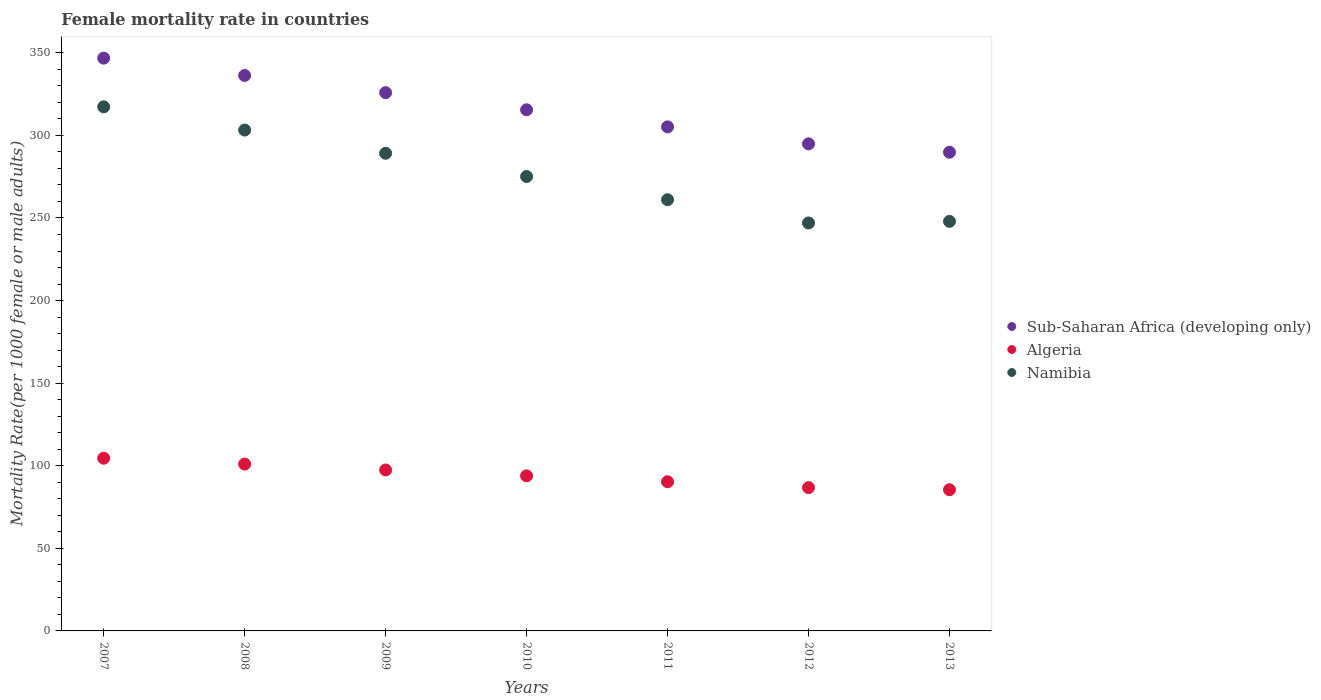What is the female mortality rate in Sub-Saharan Africa (developing only) in 2007?
Provide a short and direct response. 346.77. Across all years, what is the maximum female mortality rate in Sub-Saharan Africa (developing only)?
Your response must be concise. 346.77. Across all years, what is the minimum female mortality rate in Algeria?
Keep it short and to the point. 85.48. In which year was the female mortality rate in Sub-Saharan Africa (developing only) maximum?
Your response must be concise. 2007. In which year was the female mortality rate in Namibia minimum?
Keep it short and to the point. 2012. What is the total female mortality rate in Namibia in the graph?
Offer a terse response. 1940.83. What is the difference between the female mortality rate in Namibia in 2009 and that in 2010?
Offer a terse response. 14.06. What is the difference between the female mortality rate in Sub-Saharan Africa (developing only) in 2011 and the female mortality rate in Namibia in 2010?
Offer a very short reply. 30.05. What is the average female mortality rate in Sub-Saharan Africa (developing only) per year?
Make the answer very short. 316.33. In the year 2013, what is the difference between the female mortality rate in Algeria and female mortality rate in Sub-Saharan Africa (developing only)?
Make the answer very short. -204.33. What is the ratio of the female mortality rate in Namibia in 2010 to that in 2013?
Your response must be concise. 1.11. Is the female mortality rate in Namibia in 2009 less than that in 2011?
Make the answer very short. No. Is the difference between the female mortality rate in Algeria in 2008 and 2009 greater than the difference between the female mortality rate in Sub-Saharan Africa (developing only) in 2008 and 2009?
Provide a short and direct response. No. What is the difference between the highest and the second highest female mortality rate in Namibia?
Make the answer very short. 14.06. What is the difference between the highest and the lowest female mortality rate in Namibia?
Ensure brevity in your answer.  70.31. Is the sum of the female mortality rate in Sub-Saharan Africa (developing only) in 2011 and 2013 greater than the maximum female mortality rate in Namibia across all years?
Your response must be concise. Yes. Is it the case that in every year, the sum of the female mortality rate in Sub-Saharan Africa (developing only) and female mortality rate in Namibia  is greater than the female mortality rate in Algeria?
Ensure brevity in your answer.  Yes. Does the female mortality rate in Namibia monotonically increase over the years?
Your response must be concise. No. Is the female mortality rate in Algeria strictly less than the female mortality rate in Namibia over the years?
Your response must be concise. Yes. How many years are there in the graph?
Your answer should be compact. 7. What is the difference between two consecutive major ticks on the Y-axis?
Give a very brief answer. 50. Are the values on the major ticks of Y-axis written in scientific E-notation?
Give a very brief answer. No. Does the graph contain any zero values?
Give a very brief answer. No. Does the graph contain grids?
Provide a succinct answer. No. Where does the legend appear in the graph?
Your response must be concise. Center right. What is the title of the graph?
Provide a succinct answer. Female mortality rate in countries. Does "El Salvador" appear as one of the legend labels in the graph?
Your answer should be compact. No. What is the label or title of the X-axis?
Offer a very short reply. Years. What is the label or title of the Y-axis?
Provide a succinct answer. Mortality Rate(per 1000 female or male adults). What is the Mortality Rate(per 1000 female or male adults) of Sub-Saharan Africa (developing only) in 2007?
Offer a terse response. 346.77. What is the Mortality Rate(per 1000 female or male adults) in Algeria in 2007?
Make the answer very short. 104.57. What is the Mortality Rate(per 1000 female or male adults) of Namibia in 2007?
Give a very brief answer. 317.3. What is the Mortality Rate(per 1000 female or male adults) in Sub-Saharan Africa (developing only) in 2008?
Offer a terse response. 336.3. What is the Mortality Rate(per 1000 female or male adults) of Algeria in 2008?
Offer a very short reply. 101.01. What is the Mortality Rate(per 1000 female or male adults) of Namibia in 2008?
Your answer should be compact. 303.24. What is the Mortality Rate(per 1000 female or male adults) of Sub-Saharan Africa (developing only) in 2009?
Your answer should be very brief. 325.87. What is the Mortality Rate(per 1000 female or male adults) in Algeria in 2009?
Your answer should be compact. 97.44. What is the Mortality Rate(per 1000 female or male adults) in Namibia in 2009?
Offer a terse response. 289.17. What is the Mortality Rate(per 1000 female or male adults) of Sub-Saharan Africa (developing only) in 2010?
Give a very brief answer. 315.49. What is the Mortality Rate(per 1000 female or male adults) of Algeria in 2010?
Offer a terse response. 93.88. What is the Mortality Rate(per 1000 female or male adults) of Namibia in 2010?
Provide a short and direct response. 275.11. What is the Mortality Rate(per 1000 female or male adults) of Sub-Saharan Africa (developing only) in 2011?
Provide a succinct answer. 305.17. What is the Mortality Rate(per 1000 female or male adults) in Algeria in 2011?
Make the answer very short. 90.32. What is the Mortality Rate(per 1000 female or male adults) in Namibia in 2011?
Offer a terse response. 261.05. What is the Mortality Rate(per 1000 female or male adults) of Sub-Saharan Africa (developing only) in 2012?
Make the answer very short. 294.88. What is the Mortality Rate(per 1000 female or male adults) of Algeria in 2012?
Ensure brevity in your answer.  86.75. What is the Mortality Rate(per 1000 female or male adults) in Namibia in 2012?
Make the answer very short. 246.99. What is the Mortality Rate(per 1000 female or male adults) in Sub-Saharan Africa (developing only) in 2013?
Offer a very short reply. 289.81. What is the Mortality Rate(per 1000 female or male adults) in Algeria in 2013?
Keep it short and to the point. 85.48. What is the Mortality Rate(per 1000 female or male adults) of Namibia in 2013?
Your response must be concise. 247.97. Across all years, what is the maximum Mortality Rate(per 1000 female or male adults) in Sub-Saharan Africa (developing only)?
Ensure brevity in your answer.  346.77. Across all years, what is the maximum Mortality Rate(per 1000 female or male adults) of Algeria?
Keep it short and to the point. 104.57. Across all years, what is the maximum Mortality Rate(per 1000 female or male adults) of Namibia?
Your answer should be compact. 317.3. Across all years, what is the minimum Mortality Rate(per 1000 female or male adults) of Sub-Saharan Africa (developing only)?
Make the answer very short. 289.81. Across all years, what is the minimum Mortality Rate(per 1000 female or male adults) in Algeria?
Provide a short and direct response. 85.48. Across all years, what is the minimum Mortality Rate(per 1000 female or male adults) of Namibia?
Give a very brief answer. 246.99. What is the total Mortality Rate(per 1000 female or male adults) of Sub-Saharan Africa (developing only) in the graph?
Offer a terse response. 2214.28. What is the total Mortality Rate(per 1000 female or male adults) in Algeria in the graph?
Keep it short and to the point. 659.45. What is the total Mortality Rate(per 1000 female or male adults) in Namibia in the graph?
Give a very brief answer. 1940.83. What is the difference between the Mortality Rate(per 1000 female or male adults) in Sub-Saharan Africa (developing only) in 2007 and that in 2008?
Make the answer very short. 10.47. What is the difference between the Mortality Rate(per 1000 female or male adults) in Algeria in 2007 and that in 2008?
Give a very brief answer. 3.56. What is the difference between the Mortality Rate(per 1000 female or male adults) of Namibia in 2007 and that in 2008?
Your answer should be very brief. 14.06. What is the difference between the Mortality Rate(per 1000 female or male adults) in Sub-Saharan Africa (developing only) in 2007 and that in 2009?
Keep it short and to the point. 20.9. What is the difference between the Mortality Rate(per 1000 female or male adults) in Algeria in 2007 and that in 2009?
Provide a short and direct response. 7.13. What is the difference between the Mortality Rate(per 1000 female or male adults) in Namibia in 2007 and that in 2009?
Keep it short and to the point. 28.12. What is the difference between the Mortality Rate(per 1000 female or male adults) of Sub-Saharan Africa (developing only) in 2007 and that in 2010?
Offer a terse response. 31.27. What is the difference between the Mortality Rate(per 1000 female or male adults) of Algeria in 2007 and that in 2010?
Offer a terse response. 10.69. What is the difference between the Mortality Rate(per 1000 female or male adults) of Namibia in 2007 and that in 2010?
Keep it short and to the point. 42.19. What is the difference between the Mortality Rate(per 1000 female or male adults) of Sub-Saharan Africa (developing only) in 2007 and that in 2011?
Provide a short and direct response. 41.6. What is the difference between the Mortality Rate(per 1000 female or male adults) of Algeria in 2007 and that in 2011?
Give a very brief answer. 14.25. What is the difference between the Mortality Rate(per 1000 female or male adults) of Namibia in 2007 and that in 2011?
Offer a very short reply. 56.25. What is the difference between the Mortality Rate(per 1000 female or male adults) of Sub-Saharan Africa (developing only) in 2007 and that in 2012?
Provide a short and direct response. 51.89. What is the difference between the Mortality Rate(per 1000 female or male adults) in Algeria in 2007 and that in 2012?
Provide a succinct answer. 17.82. What is the difference between the Mortality Rate(per 1000 female or male adults) in Namibia in 2007 and that in 2012?
Provide a succinct answer. 70.31. What is the difference between the Mortality Rate(per 1000 female or male adults) in Sub-Saharan Africa (developing only) in 2007 and that in 2013?
Provide a short and direct response. 56.95. What is the difference between the Mortality Rate(per 1000 female or male adults) of Algeria in 2007 and that in 2013?
Keep it short and to the point. 19.09. What is the difference between the Mortality Rate(per 1000 female or male adults) of Namibia in 2007 and that in 2013?
Ensure brevity in your answer.  69.33. What is the difference between the Mortality Rate(per 1000 female or male adults) in Sub-Saharan Africa (developing only) in 2008 and that in 2009?
Offer a very short reply. 10.43. What is the difference between the Mortality Rate(per 1000 female or male adults) in Algeria in 2008 and that in 2009?
Keep it short and to the point. 3.56. What is the difference between the Mortality Rate(per 1000 female or male adults) in Namibia in 2008 and that in 2009?
Your response must be concise. 14.06. What is the difference between the Mortality Rate(per 1000 female or male adults) in Sub-Saharan Africa (developing only) in 2008 and that in 2010?
Offer a very short reply. 20.81. What is the difference between the Mortality Rate(per 1000 female or male adults) in Algeria in 2008 and that in 2010?
Provide a short and direct response. 7.13. What is the difference between the Mortality Rate(per 1000 female or male adults) in Namibia in 2008 and that in 2010?
Your response must be concise. 28.12. What is the difference between the Mortality Rate(per 1000 female or male adults) of Sub-Saharan Africa (developing only) in 2008 and that in 2011?
Your answer should be compact. 31.13. What is the difference between the Mortality Rate(per 1000 female or male adults) of Algeria in 2008 and that in 2011?
Provide a short and direct response. 10.69. What is the difference between the Mortality Rate(per 1000 female or male adults) of Namibia in 2008 and that in 2011?
Ensure brevity in your answer.  42.19. What is the difference between the Mortality Rate(per 1000 female or male adults) in Sub-Saharan Africa (developing only) in 2008 and that in 2012?
Your response must be concise. 41.42. What is the difference between the Mortality Rate(per 1000 female or male adults) of Algeria in 2008 and that in 2012?
Make the answer very short. 14.25. What is the difference between the Mortality Rate(per 1000 female or male adults) of Namibia in 2008 and that in 2012?
Your answer should be compact. 56.25. What is the difference between the Mortality Rate(per 1000 female or male adults) of Sub-Saharan Africa (developing only) in 2008 and that in 2013?
Offer a very short reply. 46.49. What is the difference between the Mortality Rate(per 1000 female or male adults) in Algeria in 2008 and that in 2013?
Provide a succinct answer. 15.52. What is the difference between the Mortality Rate(per 1000 female or male adults) in Namibia in 2008 and that in 2013?
Keep it short and to the point. 55.27. What is the difference between the Mortality Rate(per 1000 female or male adults) in Sub-Saharan Africa (developing only) in 2009 and that in 2010?
Offer a terse response. 10.38. What is the difference between the Mortality Rate(per 1000 female or male adults) in Algeria in 2009 and that in 2010?
Your answer should be very brief. 3.56. What is the difference between the Mortality Rate(per 1000 female or male adults) in Namibia in 2009 and that in 2010?
Your answer should be very brief. 14.06. What is the difference between the Mortality Rate(per 1000 female or male adults) in Sub-Saharan Africa (developing only) in 2009 and that in 2011?
Give a very brief answer. 20.71. What is the difference between the Mortality Rate(per 1000 female or male adults) in Algeria in 2009 and that in 2011?
Make the answer very short. 7.13. What is the difference between the Mortality Rate(per 1000 female or male adults) of Namibia in 2009 and that in 2011?
Give a very brief answer. 28.12. What is the difference between the Mortality Rate(per 1000 female or male adults) in Sub-Saharan Africa (developing only) in 2009 and that in 2012?
Provide a succinct answer. 30.99. What is the difference between the Mortality Rate(per 1000 female or male adults) of Algeria in 2009 and that in 2012?
Give a very brief answer. 10.69. What is the difference between the Mortality Rate(per 1000 female or male adults) in Namibia in 2009 and that in 2012?
Your answer should be very brief. 42.19. What is the difference between the Mortality Rate(per 1000 female or male adults) of Sub-Saharan Africa (developing only) in 2009 and that in 2013?
Give a very brief answer. 36.06. What is the difference between the Mortality Rate(per 1000 female or male adults) of Algeria in 2009 and that in 2013?
Give a very brief answer. 11.96. What is the difference between the Mortality Rate(per 1000 female or male adults) in Namibia in 2009 and that in 2013?
Provide a succinct answer. 41.21. What is the difference between the Mortality Rate(per 1000 female or male adults) of Sub-Saharan Africa (developing only) in 2010 and that in 2011?
Provide a succinct answer. 10.33. What is the difference between the Mortality Rate(per 1000 female or male adults) of Algeria in 2010 and that in 2011?
Your response must be concise. 3.56. What is the difference between the Mortality Rate(per 1000 female or male adults) of Namibia in 2010 and that in 2011?
Offer a very short reply. 14.06. What is the difference between the Mortality Rate(per 1000 female or male adults) of Sub-Saharan Africa (developing only) in 2010 and that in 2012?
Your response must be concise. 20.61. What is the difference between the Mortality Rate(per 1000 female or male adults) in Algeria in 2010 and that in 2012?
Your answer should be very brief. 7.13. What is the difference between the Mortality Rate(per 1000 female or male adults) of Namibia in 2010 and that in 2012?
Make the answer very short. 28.12. What is the difference between the Mortality Rate(per 1000 female or male adults) in Sub-Saharan Africa (developing only) in 2010 and that in 2013?
Ensure brevity in your answer.  25.68. What is the difference between the Mortality Rate(per 1000 female or male adults) of Algeria in 2010 and that in 2013?
Offer a very short reply. 8.4. What is the difference between the Mortality Rate(per 1000 female or male adults) in Namibia in 2010 and that in 2013?
Keep it short and to the point. 27.14. What is the difference between the Mortality Rate(per 1000 female or male adults) in Sub-Saharan Africa (developing only) in 2011 and that in 2012?
Make the answer very short. 10.29. What is the difference between the Mortality Rate(per 1000 female or male adults) in Algeria in 2011 and that in 2012?
Your answer should be very brief. 3.56. What is the difference between the Mortality Rate(per 1000 female or male adults) of Namibia in 2011 and that in 2012?
Your response must be concise. 14.06. What is the difference between the Mortality Rate(per 1000 female or male adults) of Sub-Saharan Africa (developing only) in 2011 and that in 2013?
Give a very brief answer. 15.35. What is the difference between the Mortality Rate(per 1000 female or male adults) of Algeria in 2011 and that in 2013?
Provide a succinct answer. 4.83. What is the difference between the Mortality Rate(per 1000 female or male adults) in Namibia in 2011 and that in 2013?
Offer a very short reply. 13.08. What is the difference between the Mortality Rate(per 1000 female or male adults) of Sub-Saharan Africa (developing only) in 2012 and that in 2013?
Keep it short and to the point. 5.07. What is the difference between the Mortality Rate(per 1000 female or male adults) of Algeria in 2012 and that in 2013?
Make the answer very short. 1.27. What is the difference between the Mortality Rate(per 1000 female or male adults) in Namibia in 2012 and that in 2013?
Offer a very short reply. -0.98. What is the difference between the Mortality Rate(per 1000 female or male adults) in Sub-Saharan Africa (developing only) in 2007 and the Mortality Rate(per 1000 female or male adults) in Algeria in 2008?
Your response must be concise. 245.76. What is the difference between the Mortality Rate(per 1000 female or male adults) in Sub-Saharan Africa (developing only) in 2007 and the Mortality Rate(per 1000 female or male adults) in Namibia in 2008?
Give a very brief answer. 43.53. What is the difference between the Mortality Rate(per 1000 female or male adults) of Algeria in 2007 and the Mortality Rate(per 1000 female or male adults) of Namibia in 2008?
Your response must be concise. -198.67. What is the difference between the Mortality Rate(per 1000 female or male adults) of Sub-Saharan Africa (developing only) in 2007 and the Mortality Rate(per 1000 female or male adults) of Algeria in 2009?
Offer a terse response. 249.32. What is the difference between the Mortality Rate(per 1000 female or male adults) of Sub-Saharan Africa (developing only) in 2007 and the Mortality Rate(per 1000 female or male adults) of Namibia in 2009?
Make the answer very short. 57.59. What is the difference between the Mortality Rate(per 1000 female or male adults) of Algeria in 2007 and the Mortality Rate(per 1000 female or male adults) of Namibia in 2009?
Offer a very short reply. -184.6. What is the difference between the Mortality Rate(per 1000 female or male adults) of Sub-Saharan Africa (developing only) in 2007 and the Mortality Rate(per 1000 female or male adults) of Algeria in 2010?
Keep it short and to the point. 252.89. What is the difference between the Mortality Rate(per 1000 female or male adults) of Sub-Saharan Africa (developing only) in 2007 and the Mortality Rate(per 1000 female or male adults) of Namibia in 2010?
Offer a very short reply. 71.65. What is the difference between the Mortality Rate(per 1000 female or male adults) of Algeria in 2007 and the Mortality Rate(per 1000 female or male adults) of Namibia in 2010?
Ensure brevity in your answer.  -170.54. What is the difference between the Mortality Rate(per 1000 female or male adults) of Sub-Saharan Africa (developing only) in 2007 and the Mortality Rate(per 1000 female or male adults) of Algeria in 2011?
Provide a short and direct response. 256.45. What is the difference between the Mortality Rate(per 1000 female or male adults) of Sub-Saharan Africa (developing only) in 2007 and the Mortality Rate(per 1000 female or male adults) of Namibia in 2011?
Make the answer very short. 85.72. What is the difference between the Mortality Rate(per 1000 female or male adults) of Algeria in 2007 and the Mortality Rate(per 1000 female or male adults) of Namibia in 2011?
Offer a very short reply. -156.48. What is the difference between the Mortality Rate(per 1000 female or male adults) in Sub-Saharan Africa (developing only) in 2007 and the Mortality Rate(per 1000 female or male adults) in Algeria in 2012?
Offer a terse response. 260.01. What is the difference between the Mortality Rate(per 1000 female or male adults) of Sub-Saharan Africa (developing only) in 2007 and the Mortality Rate(per 1000 female or male adults) of Namibia in 2012?
Your answer should be very brief. 99.78. What is the difference between the Mortality Rate(per 1000 female or male adults) in Algeria in 2007 and the Mortality Rate(per 1000 female or male adults) in Namibia in 2012?
Your response must be concise. -142.42. What is the difference between the Mortality Rate(per 1000 female or male adults) in Sub-Saharan Africa (developing only) in 2007 and the Mortality Rate(per 1000 female or male adults) in Algeria in 2013?
Your response must be concise. 261.28. What is the difference between the Mortality Rate(per 1000 female or male adults) in Sub-Saharan Africa (developing only) in 2007 and the Mortality Rate(per 1000 female or male adults) in Namibia in 2013?
Your answer should be very brief. 98.8. What is the difference between the Mortality Rate(per 1000 female or male adults) of Algeria in 2007 and the Mortality Rate(per 1000 female or male adults) of Namibia in 2013?
Your response must be concise. -143.4. What is the difference between the Mortality Rate(per 1000 female or male adults) of Sub-Saharan Africa (developing only) in 2008 and the Mortality Rate(per 1000 female or male adults) of Algeria in 2009?
Offer a terse response. 238.85. What is the difference between the Mortality Rate(per 1000 female or male adults) of Sub-Saharan Africa (developing only) in 2008 and the Mortality Rate(per 1000 female or male adults) of Namibia in 2009?
Offer a terse response. 47.12. What is the difference between the Mortality Rate(per 1000 female or male adults) in Algeria in 2008 and the Mortality Rate(per 1000 female or male adults) in Namibia in 2009?
Ensure brevity in your answer.  -188.17. What is the difference between the Mortality Rate(per 1000 female or male adults) in Sub-Saharan Africa (developing only) in 2008 and the Mortality Rate(per 1000 female or male adults) in Algeria in 2010?
Your answer should be very brief. 242.42. What is the difference between the Mortality Rate(per 1000 female or male adults) of Sub-Saharan Africa (developing only) in 2008 and the Mortality Rate(per 1000 female or male adults) of Namibia in 2010?
Your response must be concise. 61.19. What is the difference between the Mortality Rate(per 1000 female or male adults) in Algeria in 2008 and the Mortality Rate(per 1000 female or male adults) in Namibia in 2010?
Your answer should be compact. -174.11. What is the difference between the Mortality Rate(per 1000 female or male adults) of Sub-Saharan Africa (developing only) in 2008 and the Mortality Rate(per 1000 female or male adults) of Algeria in 2011?
Make the answer very short. 245.98. What is the difference between the Mortality Rate(per 1000 female or male adults) in Sub-Saharan Africa (developing only) in 2008 and the Mortality Rate(per 1000 female or male adults) in Namibia in 2011?
Give a very brief answer. 75.25. What is the difference between the Mortality Rate(per 1000 female or male adults) of Algeria in 2008 and the Mortality Rate(per 1000 female or male adults) of Namibia in 2011?
Your answer should be compact. -160.04. What is the difference between the Mortality Rate(per 1000 female or male adults) of Sub-Saharan Africa (developing only) in 2008 and the Mortality Rate(per 1000 female or male adults) of Algeria in 2012?
Keep it short and to the point. 249.54. What is the difference between the Mortality Rate(per 1000 female or male adults) in Sub-Saharan Africa (developing only) in 2008 and the Mortality Rate(per 1000 female or male adults) in Namibia in 2012?
Your response must be concise. 89.31. What is the difference between the Mortality Rate(per 1000 female or male adults) in Algeria in 2008 and the Mortality Rate(per 1000 female or male adults) in Namibia in 2012?
Make the answer very short. -145.98. What is the difference between the Mortality Rate(per 1000 female or male adults) in Sub-Saharan Africa (developing only) in 2008 and the Mortality Rate(per 1000 female or male adults) in Algeria in 2013?
Your answer should be compact. 250.82. What is the difference between the Mortality Rate(per 1000 female or male adults) in Sub-Saharan Africa (developing only) in 2008 and the Mortality Rate(per 1000 female or male adults) in Namibia in 2013?
Your response must be concise. 88.33. What is the difference between the Mortality Rate(per 1000 female or male adults) in Algeria in 2008 and the Mortality Rate(per 1000 female or male adults) in Namibia in 2013?
Make the answer very short. -146.96. What is the difference between the Mortality Rate(per 1000 female or male adults) of Sub-Saharan Africa (developing only) in 2009 and the Mortality Rate(per 1000 female or male adults) of Algeria in 2010?
Ensure brevity in your answer.  231.99. What is the difference between the Mortality Rate(per 1000 female or male adults) in Sub-Saharan Africa (developing only) in 2009 and the Mortality Rate(per 1000 female or male adults) in Namibia in 2010?
Ensure brevity in your answer.  50.76. What is the difference between the Mortality Rate(per 1000 female or male adults) in Algeria in 2009 and the Mortality Rate(per 1000 female or male adults) in Namibia in 2010?
Give a very brief answer. -177.67. What is the difference between the Mortality Rate(per 1000 female or male adults) in Sub-Saharan Africa (developing only) in 2009 and the Mortality Rate(per 1000 female or male adults) in Algeria in 2011?
Provide a short and direct response. 235.55. What is the difference between the Mortality Rate(per 1000 female or male adults) of Sub-Saharan Africa (developing only) in 2009 and the Mortality Rate(per 1000 female or male adults) of Namibia in 2011?
Make the answer very short. 64.82. What is the difference between the Mortality Rate(per 1000 female or male adults) in Algeria in 2009 and the Mortality Rate(per 1000 female or male adults) in Namibia in 2011?
Provide a short and direct response. -163.61. What is the difference between the Mortality Rate(per 1000 female or male adults) in Sub-Saharan Africa (developing only) in 2009 and the Mortality Rate(per 1000 female or male adults) in Algeria in 2012?
Offer a very short reply. 239.12. What is the difference between the Mortality Rate(per 1000 female or male adults) in Sub-Saharan Africa (developing only) in 2009 and the Mortality Rate(per 1000 female or male adults) in Namibia in 2012?
Your answer should be very brief. 78.88. What is the difference between the Mortality Rate(per 1000 female or male adults) in Algeria in 2009 and the Mortality Rate(per 1000 female or male adults) in Namibia in 2012?
Offer a terse response. -149.54. What is the difference between the Mortality Rate(per 1000 female or male adults) in Sub-Saharan Africa (developing only) in 2009 and the Mortality Rate(per 1000 female or male adults) in Algeria in 2013?
Provide a succinct answer. 240.39. What is the difference between the Mortality Rate(per 1000 female or male adults) in Sub-Saharan Africa (developing only) in 2009 and the Mortality Rate(per 1000 female or male adults) in Namibia in 2013?
Offer a very short reply. 77.9. What is the difference between the Mortality Rate(per 1000 female or male adults) in Algeria in 2009 and the Mortality Rate(per 1000 female or male adults) in Namibia in 2013?
Make the answer very short. -150.53. What is the difference between the Mortality Rate(per 1000 female or male adults) of Sub-Saharan Africa (developing only) in 2010 and the Mortality Rate(per 1000 female or male adults) of Algeria in 2011?
Ensure brevity in your answer.  225.18. What is the difference between the Mortality Rate(per 1000 female or male adults) in Sub-Saharan Africa (developing only) in 2010 and the Mortality Rate(per 1000 female or male adults) in Namibia in 2011?
Give a very brief answer. 54.44. What is the difference between the Mortality Rate(per 1000 female or male adults) of Algeria in 2010 and the Mortality Rate(per 1000 female or male adults) of Namibia in 2011?
Your response must be concise. -167.17. What is the difference between the Mortality Rate(per 1000 female or male adults) of Sub-Saharan Africa (developing only) in 2010 and the Mortality Rate(per 1000 female or male adults) of Algeria in 2012?
Your answer should be very brief. 228.74. What is the difference between the Mortality Rate(per 1000 female or male adults) in Sub-Saharan Africa (developing only) in 2010 and the Mortality Rate(per 1000 female or male adults) in Namibia in 2012?
Ensure brevity in your answer.  68.5. What is the difference between the Mortality Rate(per 1000 female or male adults) of Algeria in 2010 and the Mortality Rate(per 1000 female or male adults) of Namibia in 2012?
Offer a very short reply. -153.11. What is the difference between the Mortality Rate(per 1000 female or male adults) of Sub-Saharan Africa (developing only) in 2010 and the Mortality Rate(per 1000 female or male adults) of Algeria in 2013?
Your answer should be very brief. 230.01. What is the difference between the Mortality Rate(per 1000 female or male adults) of Sub-Saharan Africa (developing only) in 2010 and the Mortality Rate(per 1000 female or male adults) of Namibia in 2013?
Give a very brief answer. 67.52. What is the difference between the Mortality Rate(per 1000 female or male adults) of Algeria in 2010 and the Mortality Rate(per 1000 female or male adults) of Namibia in 2013?
Provide a short and direct response. -154.09. What is the difference between the Mortality Rate(per 1000 female or male adults) in Sub-Saharan Africa (developing only) in 2011 and the Mortality Rate(per 1000 female or male adults) in Algeria in 2012?
Keep it short and to the point. 218.41. What is the difference between the Mortality Rate(per 1000 female or male adults) of Sub-Saharan Africa (developing only) in 2011 and the Mortality Rate(per 1000 female or male adults) of Namibia in 2012?
Offer a very short reply. 58.18. What is the difference between the Mortality Rate(per 1000 female or male adults) in Algeria in 2011 and the Mortality Rate(per 1000 female or male adults) in Namibia in 2012?
Your answer should be compact. -156.67. What is the difference between the Mortality Rate(per 1000 female or male adults) of Sub-Saharan Africa (developing only) in 2011 and the Mortality Rate(per 1000 female or male adults) of Algeria in 2013?
Make the answer very short. 219.68. What is the difference between the Mortality Rate(per 1000 female or male adults) of Sub-Saharan Africa (developing only) in 2011 and the Mortality Rate(per 1000 female or male adults) of Namibia in 2013?
Provide a succinct answer. 57.2. What is the difference between the Mortality Rate(per 1000 female or male adults) of Algeria in 2011 and the Mortality Rate(per 1000 female or male adults) of Namibia in 2013?
Provide a short and direct response. -157.65. What is the difference between the Mortality Rate(per 1000 female or male adults) in Sub-Saharan Africa (developing only) in 2012 and the Mortality Rate(per 1000 female or male adults) in Algeria in 2013?
Ensure brevity in your answer.  209.4. What is the difference between the Mortality Rate(per 1000 female or male adults) of Sub-Saharan Africa (developing only) in 2012 and the Mortality Rate(per 1000 female or male adults) of Namibia in 2013?
Ensure brevity in your answer.  46.91. What is the difference between the Mortality Rate(per 1000 female or male adults) in Algeria in 2012 and the Mortality Rate(per 1000 female or male adults) in Namibia in 2013?
Provide a succinct answer. -161.22. What is the average Mortality Rate(per 1000 female or male adults) of Sub-Saharan Africa (developing only) per year?
Make the answer very short. 316.33. What is the average Mortality Rate(per 1000 female or male adults) in Algeria per year?
Your answer should be compact. 94.21. What is the average Mortality Rate(per 1000 female or male adults) in Namibia per year?
Provide a short and direct response. 277.26. In the year 2007, what is the difference between the Mortality Rate(per 1000 female or male adults) in Sub-Saharan Africa (developing only) and Mortality Rate(per 1000 female or male adults) in Algeria?
Give a very brief answer. 242.2. In the year 2007, what is the difference between the Mortality Rate(per 1000 female or male adults) of Sub-Saharan Africa (developing only) and Mortality Rate(per 1000 female or male adults) of Namibia?
Give a very brief answer. 29.47. In the year 2007, what is the difference between the Mortality Rate(per 1000 female or male adults) in Algeria and Mortality Rate(per 1000 female or male adults) in Namibia?
Ensure brevity in your answer.  -212.73. In the year 2008, what is the difference between the Mortality Rate(per 1000 female or male adults) in Sub-Saharan Africa (developing only) and Mortality Rate(per 1000 female or male adults) in Algeria?
Keep it short and to the point. 235.29. In the year 2008, what is the difference between the Mortality Rate(per 1000 female or male adults) in Sub-Saharan Africa (developing only) and Mortality Rate(per 1000 female or male adults) in Namibia?
Your answer should be compact. 33.06. In the year 2008, what is the difference between the Mortality Rate(per 1000 female or male adults) in Algeria and Mortality Rate(per 1000 female or male adults) in Namibia?
Your answer should be compact. -202.23. In the year 2009, what is the difference between the Mortality Rate(per 1000 female or male adults) of Sub-Saharan Africa (developing only) and Mortality Rate(per 1000 female or male adults) of Algeria?
Your answer should be very brief. 228.43. In the year 2009, what is the difference between the Mortality Rate(per 1000 female or male adults) in Sub-Saharan Africa (developing only) and Mortality Rate(per 1000 female or male adults) in Namibia?
Provide a succinct answer. 36.7. In the year 2009, what is the difference between the Mortality Rate(per 1000 female or male adults) of Algeria and Mortality Rate(per 1000 female or male adults) of Namibia?
Offer a terse response. -191.73. In the year 2010, what is the difference between the Mortality Rate(per 1000 female or male adults) in Sub-Saharan Africa (developing only) and Mortality Rate(per 1000 female or male adults) in Algeria?
Your answer should be compact. 221.61. In the year 2010, what is the difference between the Mortality Rate(per 1000 female or male adults) of Sub-Saharan Africa (developing only) and Mortality Rate(per 1000 female or male adults) of Namibia?
Provide a succinct answer. 40.38. In the year 2010, what is the difference between the Mortality Rate(per 1000 female or male adults) of Algeria and Mortality Rate(per 1000 female or male adults) of Namibia?
Your answer should be very brief. -181.23. In the year 2011, what is the difference between the Mortality Rate(per 1000 female or male adults) in Sub-Saharan Africa (developing only) and Mortality Rate(per 1000 female or male adults) in Algeria?
Provide a succinct answer. 214.85. In the year 2011, what is the difference between the Mortality Rate(per 1000 female or male adults) of Sub-Saharan Africa (developing only) and Mortality Rate(per 1000 female or male adults) of Namibia?
Your answer should be compact. 44.12. In the year 2011, what is the difference between the Mortality Rate(per 1000 female or male adults) of Algeria and Mortality Rate(per 1000 female or male adults) of Namibia?
Your answer should be compact. -170.73. In the year 2012, what is the difference between the Mortality Rate(per 1000 female or male adults) of Sub-Saharan Africa (developing only) and Mortality Rate(per 1000 female or male adults) of Algeria?
Provide a short and direct response. 208.12. In the year 2012, what is the difference between the Mortality Rate(per 1000 female or male adults) in Sub-Saharan Africa (developing only) and Mortality Rate(per 1000 female or male adults) in Namibia?
Ensure brevity in your answer.  47.89. In the year 2012, what is the difference between the Mortality Rate(per 1000 female or male adults) of Algeria and Mortality Rate(per 1000 female or male adults) of Namibia?
Provide a succinct answer. -160.24. In the year 2013, what is the difference between the Mortality Rate(per 1000 female or male adults) in Sub-Saharan Africa (developing only) and Mortality Rate(per 1000 female or male adults) in Algeria?
Your response must be concise. 204.33. In the year 2013, what is the difference between the Mortality Rate(per 1000 female or male adults) in Sub-Saharan Africa (developing only) and Mortality Rate(per 1000 female or male adults) in Namibia?
Ensure brevity in your answer.  41.84. In the year 2013, what is the difference between the Mortality Rate(per 1000 female or male adults) in Algeria and Mortality Rate(per 1000 female or male adults) in Namibia?
Your answer should be compact. -162.49. What is the ratio of the Mortality Rate(per 1000 female or male adults) in Sub-Saharan Africa (developing only) in 2007 to that in 2008?
Provide a succinct answer. 1.03. What is the ratio of the Mortality Rate(per 1000 female or male adults) in Algeria in 2007 to that in 2008?
Keep it short and to the point. 1.04. What is the ratio of the Mortality Rate(per 1000 female or male adults) in Namibia in 2007 to that in 2008?
Keep it short and to the point. 1.05. What is the ratio of the Mortality Rate(per 1000 female or male adults) in Sub-Saharan Africa (developing only) in 2007 to that in 2009?
Give a very brief answer. 1.06. What is the ratio of the Mortality Rate(per 1000 female or male adults) of Algeria in 2007 to that in 2009?
Your answer should be compact. 1.07. What is the ratio of the Mortality Rate(per 1000 female or male adults) in Namibia in 2007 to that in 2009?
Provide a short and direct response. 1.1. What is the ratio of the Mortality Rate(per 1000 female or male adults) in Sub-Saharan Africa (developing only) in 2007 to that in 2010?
Your answer should be very brief. 1.1. What is the ratio of the Mortality Rate(per 1000 female or male adults) in Algeria in 2007 to that in 2010?
Ensure brevity in your answer.  1.11. What is the ratio of the Mortality Rate(per 1000 female or male adults) of Namibia in 2007 to that in 2010?
Give a very brief answer. 1.15. What is the ratio of the Mortality Rate(per 1000 female or male adults) of Sub-Saharan Africa (developing only) in 2007 to that in 2011?
Your answer should be very brief. 1.14. What is the ratio of the Mortality Rate(per 1000 female or male adults) in Algeria in 2007 to that in 2011?
Make the answer very short. 1.16. What is the ratio of the Mortality Rate(per 1000 female or male adults) of Namibia in 2007 to that in 2011?
Give a very brief answer. 1.22. What is the ratio of the Mortality Rate(per 1000 female or male adults) of Sub-Saharan Africa (developing only) in 2007 to that in 2012?
Provide a short and direct response. 1.18. What is the ratio of the Mortality Rate(per 1000 female or male adults) in Algeria in 2007 to that in 2012?
Provide a short and direct response. 1.21. What is the ratio of the Mortality Rate(per 1000 female or male adults) of Namibia in 2007 to that in 2012?
Offer a very short reply. 1.28. What is the ratio of the Mortality Rate(per 1000 female or male adults) of Sub-Saharan Africa (developing only) in 2007 to that in 2013?
Offer a terse response. 1.2. What is the ratio of the Mortality Rate(per 1000 female or male adults) of Algeria in 2007 to that in 2013?
Offer a terse response. 1.22. What is the ratio of the Mortality Rate(per 1000 female or male adults) in Namibia in 2007 to that in 2013?
Your answer should be compact. 1.28. What is the ratio of the Mortality Rate(per 1000 female or male adults) of Sub-Saharan Africa (developing only) in 2008 to that in 2009?
Make the answer very short. 1.03. What is the ratio of the Mortality Rate(per 1000 female or male adults) of Algeria in 2008 to that in 2009?
Offer a terse response. 1.04. What is the ratio of the Mortality Rate(per 1000 female or male adults) of Namibia in 2008 to that in 2009?
Your answer should be compact. 1.05. What is the ratio of the Mortality Rate(per 1000 female or male adults) in Sub-Saharan Africa (developing only) in 2008 to that in 2010?
Ensure brevity in your answer.  1.07. What is the ratio of the Mortality Rate(per 1000 female or male adults) in Algeria in 2008 to that in 2010?
Your response must be concise. 1.08. What is the ratio of the Mortality Rate(per 1000 female or male adults) of Namibia in 2008 to that in 2010?
Your answer should be compact. 1.1. What is the ratio of the Mortality Rate(per 1000 female or male adults) in Sub-Saharan Africa (developing only) in 2008 to that in 2011?
Give a very brief answer. 1.1. What is the ratio of the Mortality Rate(per 1000 female or male adults) in Algeria in 2008 to that in 2011?
Provide a short and direct response. 1.12. What is the ratio of the Mortality Rate(per 1000 female or male adults) of Namibia in 2008 to that in 2011?
Keep it short and to the point. 1.16. What is the ratio of the Mortality Rate(per 1000 female or male adults) in Sub-Saharan Africa (developing only) in 2008 to that in 2012?
Make the answer very short. 1.14. What is the ratio of the Mortality Rate(per 1000 female or male adults) in Algeria in 2008 to that in 2012?
Keep it short and to the point. 1.16. What is the ratio of the Mortality Rate(per 1000 female or male adults) of Namibia in 2008 to that in 2012?
Provide a succinct answer. 1.23. What is the ratio of the Mortality Rate(per 1000 female or male adults) in Sub-Saharan Africa (developing only) in 2008 to that in 2013?
Offer a terse response. 1.16. What is the ratio of the Mortality Rate(per 1000 female or male adults) in Algeria in 2008 to that in 2013?
Offer a terse response. 1.18. What is the ratio of the Mortality Rate(per 1000 female or male adults) in Namibia in 2008 to that in 2013?
Offer a very short reply. 1.22. What is the ratio of the Mortality Rate(per 1000 female or male adults) in Sub-Saharan Africa (developing only) in 2009 to that in 2010?
Your response must be concise. 1.03. What is the ratio of the Mortality Rate(per 1000 female or male adults) in Algeria in 2009 to that in 2010?
Your answer should be compact. 1.04. What is the ratio of the Mortality Rate(per 1000 female or male adults) in Namibia in 2009 to that in 2010?
Keep it short and to the point. 1.05. What is the ratio of the Mortality Rate(per 1000 female or male adults) of Sub-Saharan Africa (developing only) in 2009 to that in 2011?
Ensure brevity in your answer.  1.07. What is the ratio of the Mortality Rate(per 1000 female or male adults) of Algeria in 2009 to that in 2011?
Your answer should be compact. 1.08. What is the ratio of the Mortality Rate(per 1000 female or male adults) of Namibia in 2009 to that in 2011?
Offer a very short reply. 1.11. What is the ratio of the Mortality Rate(per 1000 female or male adults) in Sub-Saharan Africa (developing only) in 2009 to that in 2012?
Provide a short and direct response. 1.11. What is the ratio of the Mortality Rate(per 1000 female or male adults) in Algeria in 2009 to that in 2012?
Offer a very short reply. 1.12. What is the ratio of the Mortality Rate(per 1000 female or male adults) in Namibia in 2009 to that in 2012?
Make the answer very short. 1.17. What is the ratio of the Mortality Rate(per 1000 female or male adults) in Sub-Saharan Africa (developing only) in 2009 to that in 2013?
Your response must be concise. 1.12. What is the ratio of the Mortality Rate(per 1000 female or male adults) of Algeria in 2009 to that in 2013?
Your answer should be compact. 1.14. What is the ratio of the Mortality Rate(per 1000 female or male adults) in Namibia in 2009 to that in 2013?
Offer a terse response. 1.17. What is the ratio of the Mortality Rate(per 1000 female or male adults) of Sub-Saharan Africa (developing only) in 2010 to that in 2011?
Provide a short and direct response. 1.03. What is the ratio of the Mortality Rate(per 1000 female or male adults) of Algeria in 2010 to that in 2011?
Keep it short and to the point. 1.04. What is the ratio of the Mortality Rate(per 1000 female or male adults) of Namibia in 2010 to that in 2011?
Your answer should be compact. 1.05. What is the ratio of the Mortality Rate(per 1000 female or male adults) of Sub-Saharan Africa (developing only) in 2010 to that in 2012?
Your answer should be compact. 1.07. What is the ratio of the Mortality Rate(per 1000 female or male adults) in Algeria in 2010 to that in 2012?
Offer a terse response. 1.08. What is the ratio of the Mortality Rate(per 1000 female or male adults) of Namibia in 2010 to that in 2012?
Your response must be concise. 1.11. What is the ratio of the Mortality Rate(per 1000 female or male adults) of Sub-Saharan Africa (developing only) in 2010 to that in 2013?
Your answer should be compact. 1.09. What is the ratio of the Mortality Rate(per 1000 female or male adults) of Algeria in 2010 to that in 2013?
Offer a very short reply. 1.1. What is the ratio of the Mortality Rate(per 1000 female or male adults) in Namibia in 2010 to that in 2013?
Make the answer very short. 1.11. What is the ratio of the Mortality Rate(per 1000 female or male adults) of Sub-Saharan Africa (developing only) in 2011 to that in 2012?
Offer a terse response. 1.03. What is the ratio of the Mortality Rate(per 1000 female or male adults) of Algeria in 2011 to that in 2012?
Provide a short and direct response. 1.04. What is the ratio of the Mortality Rate(per 1000 female or male adults) in Namibia in 2011 to that in 2012?
Make the answer very short. 1.06. What is the ratio of the Mortality Rate(per 1000 female or male adults) in Sub-Saharan Africa (developing only) in 2011 to that in 2013?
Keep it short and to the point. 1.05. What is the ratio of the Mortality Rate(per 1000 female or male adults) of Algeria in 2011 to that in 2013?
Keep it short and to the point. 1.06. What is the ratio of the Mortality Rate(per 1000 female or male adults) of Namibia in 2011 to that in 2013?
Your answer should be very brief. 1.05. What is the ratio of the Mortality Rate(per 1000 female or male adults) of Sub-Saharan Africa (developing only) in 2012 to that in 2013?
Your answer should be compact. 1.02. What is the ratio of the Mortality Rate(per 1000 female or male adults) in Algeria in 2012 to that in 2013?
Keep it short and to the point. 1.01. What is the difference between the highest and the second highest Mortality Rate(per 1000 female or male adults) of Sub-Saharan Africa (developing only)?
Your answer should be very brief. 10.47. What is the difference between the highest and the second highest Mortality Rate(per 1000 female or male adults) of Algeria?
Offer a terse response. 3.56. What is the difference between the highest and the second highest Mortality Rate(per 1000 female or male adults) in Namibia?
Provide a succinct answer. 14.06. What is the difference between the highest and the lowest Mortality Rate(per 1000 female or male adults) of Sub-Saharan Africa (developing only)?
Make the answer very short. 56.95. What is the difference between the highest and the lowest Mortality Rate(per 1000 female or male adults) of Algeria?
Give a very brief answer. 19.09. What is the difference between the highest and the lowest Mortality Rate(per 1000 female or male adults) of Namibia?
Your answer should be very brief. 70.31. 